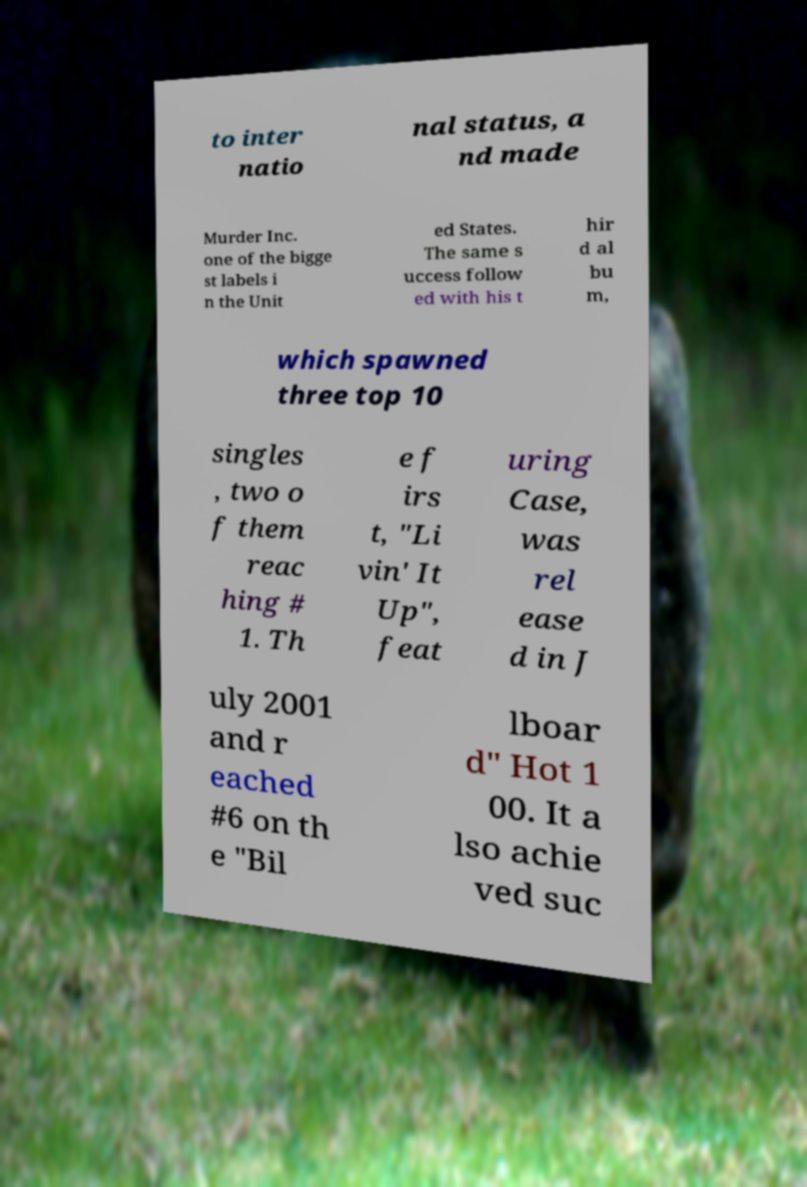Please read and relay the text visible in this image. What does it say? to inter natio nal status, a nd made Murder Inc. one of the bigge st labels i n the Unit ed States. The same s uccess follow ed with his t hir d al bu m, which spawned three top 10 singles , two o f them reac hing # 1. Th e f irs t, "Li vin' It Up", feat uring Case, was rel ease d in J uly 2001 and r eached #6 on th e "Bil lboar d" Hot 1 00. It a lso achie ved suc 